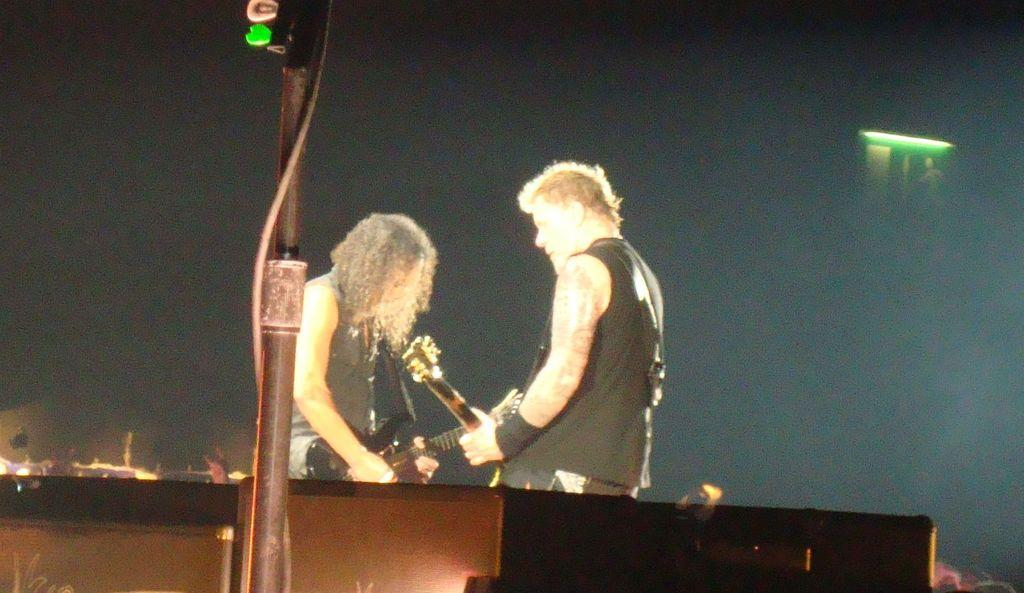How many people are in the image? There are two men in the image. What are the men doing in the image? The men are standing and playing guitar. What is the platform-like structure in the image? There is a dais in the image. What type of seed can be seen growing on the dais in the image? There is no seed growing on the dais in the image; it is a platform-like structure. 